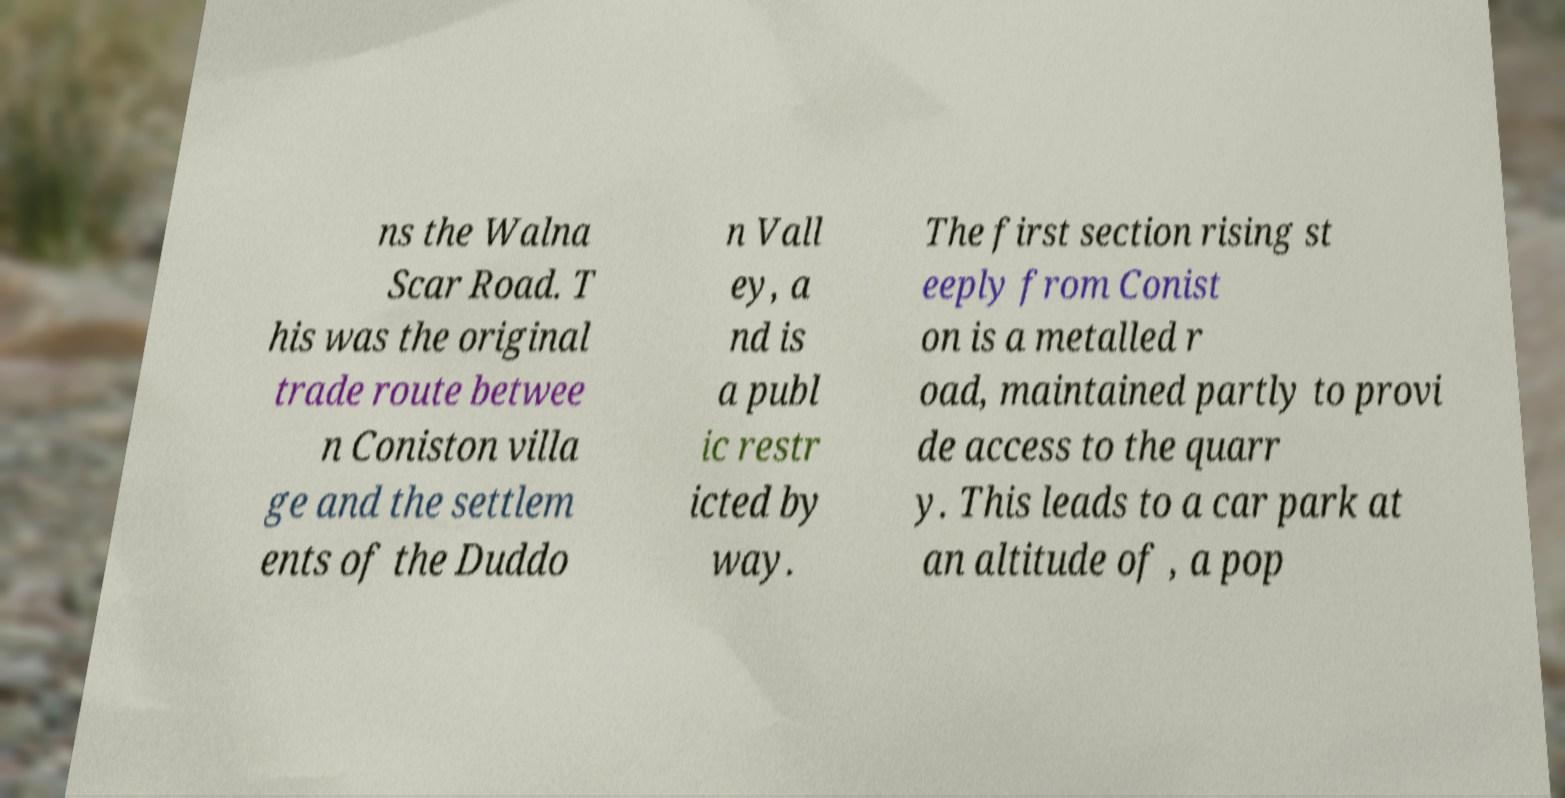Could you extract and type out the text from this image? ns the Walna Scar Road. T his was the original trade route betwee n Coniston villa ge and the settlem ents of the Duddo n Vall ey, a nd is a publ ic restr icted by way. The first section rising st eeply from Conist on is a metalled r oad, maintained partly to provi de access to the quarr y. This leads to a car park at an altitude of , a pop 